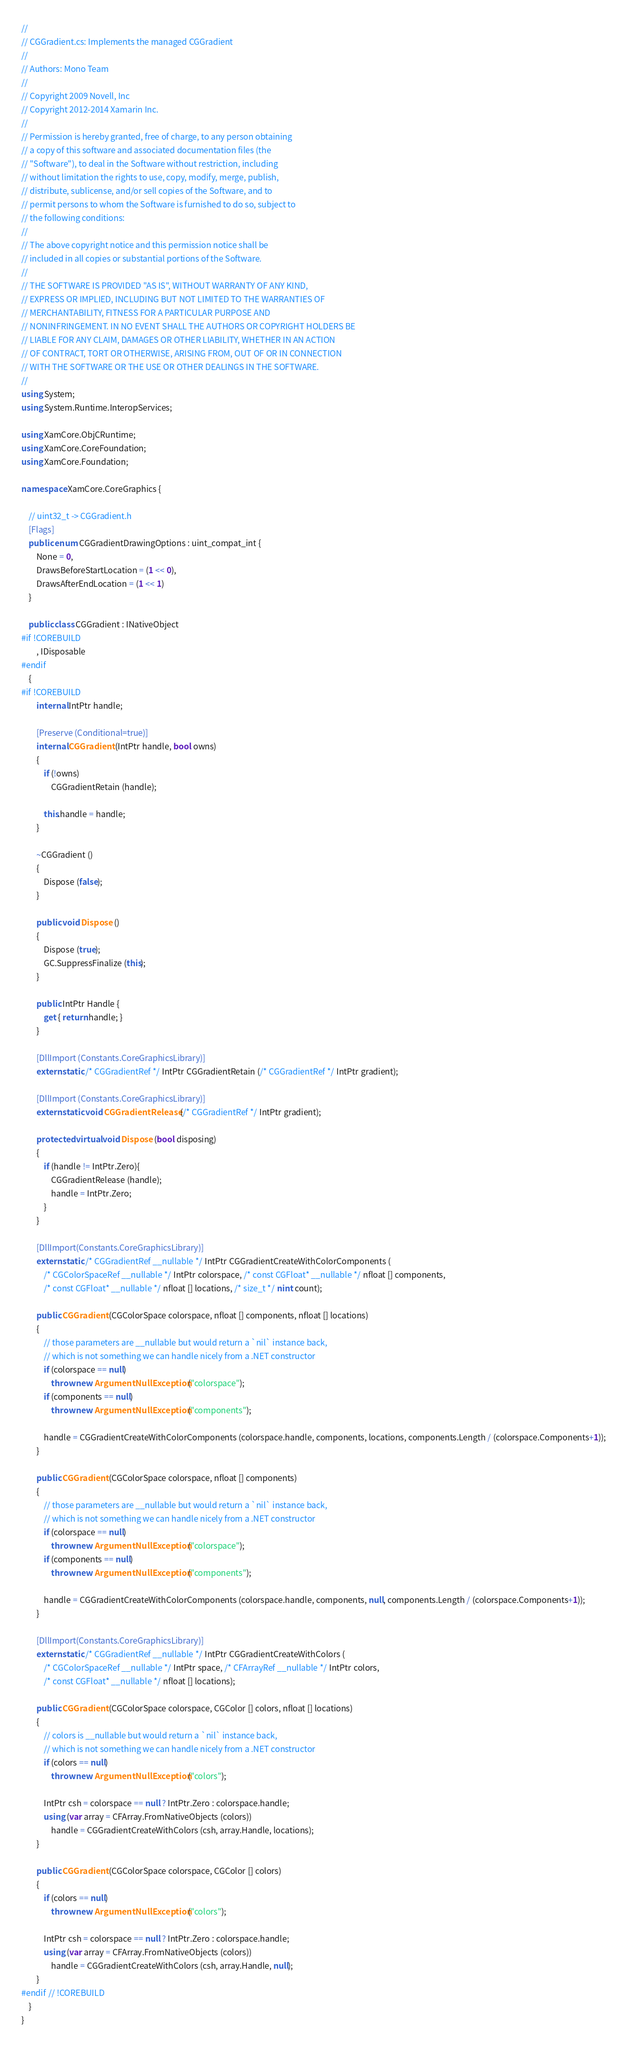Convert code to text. <code><loc_0><loc_0><loc_500><loc_500><_C#_>// 
// CGGradient.cs: Implements the managed CGGradient
//
// Authors: Mono Team
//     
// Copyright 2009 Novell, Inc
// Copyright 2012-2014 Xamarin Inc.
//
// Permission is hereby granted, free of charge, to any person obtaining
// a copy of this software and associated documentation files (the
// "Software"), to deal in the Software without restriction, including
// without limitation the rights to use, copy, modify, merge, publish,
// distribute, sublicense, and/or sell copies of the Software, and to
// permit persons to whom the Software is furnished to do so, subject to
// the following conditions:
// 
// The above copyright notice and this permission notice shall be
// included in all copies or substantial portions of the Software.
// 
// THE SOFTWARE IS PROVIDED "AS IS", WITHOUT WARRANTY OF ANY KIND,
// EXPRESS OR IMPLIED, INCLUDING BUT NOT LIMITED TO THE WARRANTIES OF
// MERCHANTABILITY, FITNESS FOR A PARTICULAR PURPOSE AND
// NONINFRINGEMENT. IN NO EVENT SHALL THE AUTHORS OR COPYRIGHT HOLDERS BE
// LIABLE FOR ANY CLAIM, DAMAGES OR OTHER LIABILITY, WHETHER IN AN ACTION
// OF CONTRACT, TORT OR OTHERWISE, ARISING FROM, OUT OF OR IN CONNECTION
// WITH THE SOFTWARE OR THE USE OR OTHER DEALINGS IN THE SOFTWARE.
//
using System;
using System.Runtime.InteropServices;

using XamCore.ObjCRuntime;
using XamCore.CoreFoundation;
using XamCore.Foundation;

namespace XamCore.CoreGraphics {

	// uint32_t -> CGGradient.h
	[Flags]
	public enum CGGradientDrawingOptions : uint_compat_int {
		None = 0,
		DrawsBeforeStartLocation = (1 << 0),
		DrawsAfterEndLocation = (1 << 1)
	}
	
	public class CGGradient : INativeObject
#if !COREBUILD
		, IDisposable
#endif
	{
#if !COREBUILD
		internal IntPtr handle;

		[Preserve (Conditional=true)]
		internal CGGradient (IntPtr handle, bool owns)
		{
			if (!owns)
				CGGradientRetain (handle);

			this.handle = handle;
		}

		~CGGradient ()
		{
			Dispose (false);
		}
		
		public void Dispose ()
		{
			Dispose (true);
			GC.SuppressFinalize (this);
		}

		public IntPtr Handle {
			get { return handle; }
		}
	
		[DllImport (Constants.CoreGraphicsLibrary)]
		extern static /* CGGradientRef */ IntPtr CGGradientRetain (/* CGGradientRef */ IntPtr gradient);

		[DllImport (Constants.CoreGraphicsLibrary)]
		extern static void CGGradientRelease (/* CGGradientRef */ IntPtr gradient);
		
		protected virtual void Dispose (bool disposing)
		{
			if (handle != IntPtr.Zero){
				CGGradientRelease (handle);
				handle = IntPtr.Zero;
			}
		}

		[DllImport(Constants.CoreGraphicsLibrary)]
		extern static /* CGGradientRef __nullable */ IntPtr CGGradientCreateWithColorComponents (
			/* CGColorSpaceRef __nullable */ IntPtr colorspace, /* const CGFloat* __nullable */ nfloat [] components, 
			/* const CGFloat* __nullable */ nfloat [] locations, /* size_t */ nint count);

		public CGGradient (CGColorSpace colorspace, nfloat [] components, nfloat [] locations)
		{
			// those parameters are __nullable but would return a `nil` instance back,
			// which is not something we can handle nicely from a .NET constructor
			if (colorspace == null)
				throw new ArgumentNullException ("colorspace");
			if (components == null)
				throw new ArgumentNullException ("components");

			handle = CGGradientCreateWithColorComponents (colorspace.handle, components, locations, components.Length / (colorspace.Components+1));
		}

		public CGGradient (CGColorSpace colorspace, nfloat [] components)
		{
			// those parameters are __nullable but would return a `nil` instance back,
			// which is not something we can handle nicely from a .NET constructor
			if (colorspace == null)
				throw new ArgumentNullException ("colorspace");
			if (components == null)
				throw new ArgumentNullException ("components");

			handle = CGGradientCreateWithColorComponents (colorspace.handle, components, null, components.Length / (colorspace.Components+1));
		}

		[DllImport(Constants.CoreGraphicsLibrary)]
		extern static /* CGGradientRef __nullable */ IntPtr CGGradientCreateWithColors (
			/* CGColorSpaceRef __nullable */ IntPtr space, /* CFArrayRef __nullable */ IntPtr colors, 
			/* const CGFloat* __nullable */ nfloat [] locations);

		public CGGradient (CGColorSpace colorspace, CGColor [] colors, nfloat [] locations)
		{
			// colors is __nullable but would return a `nil` instance back,
			// which is not something we can handle nicely from a .NET constructor
			if (colors == null)
				throw new ArgumentNullException ("colors");
			
			IntPtr csh = colorspace == null ? IntPtr.Zero : colorspace.handle;
			using (var array = CFArray.FromNativeObjects (colors))
				handle = CGGradientCreateWithColors (csh, array.Handle, locations);
		}

		public CGGradient (CGColorSpace colorspace, CGColor [] colors)
		{
			if (colors == null)
				throw new ArgumentNullException ("colors");
			
			IntPtr csh = colorspace == null ? IntPtr.Zero : colorspace.handle;
			using (var array = CFArray.FromNativeObjects (colors))
				handle = CGGradientCreateWithColors (csh, array.Handle, null);
		}
#endif // !COREBUILD
	}
}
</code> 